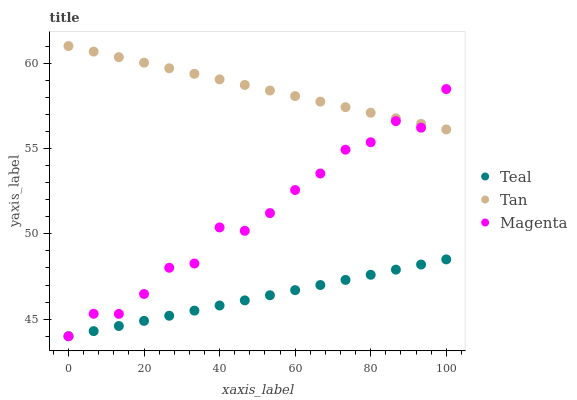Does Teal have the minimum area under the curve?
Answer yes or no. Yes. Does Tan have the maximum area under the curve?
Answer yes or no. Yes. Does Magenta have the minimum area under the curve?
Answer yes or no. No. Does Magenta have the maximum area under the curve?
Answer yes or no. No. Is Tan the smoothest?
Answer yes or no. Yes. Is Magenta the roughest?
Answer yes or no. Yes. Is Teal the smoothest?
Answer yes or no. No. Is Teal the roughest?
Answer yes or no. No. Does Magenta have the lowest value?
Answer yes or no. Yes. Does Tan have the highest value?
Answer yes or no. Yes. Does Magenta have the highest value?
Answer yes or no. No. Is Teal less than Tan?
Answer yes or no. Yes. Is Tan greater than Teal?
Answer yes or no. Yes. Does Teal intersect Magenta?
Answer yes or no. Yes. Is Teal less than Magenta?
Answer yes or no. No. Is Teal greater than Magenta?
Answer yes or no. No. Does Teal intersect Tan?
Answer yes or no. No. 